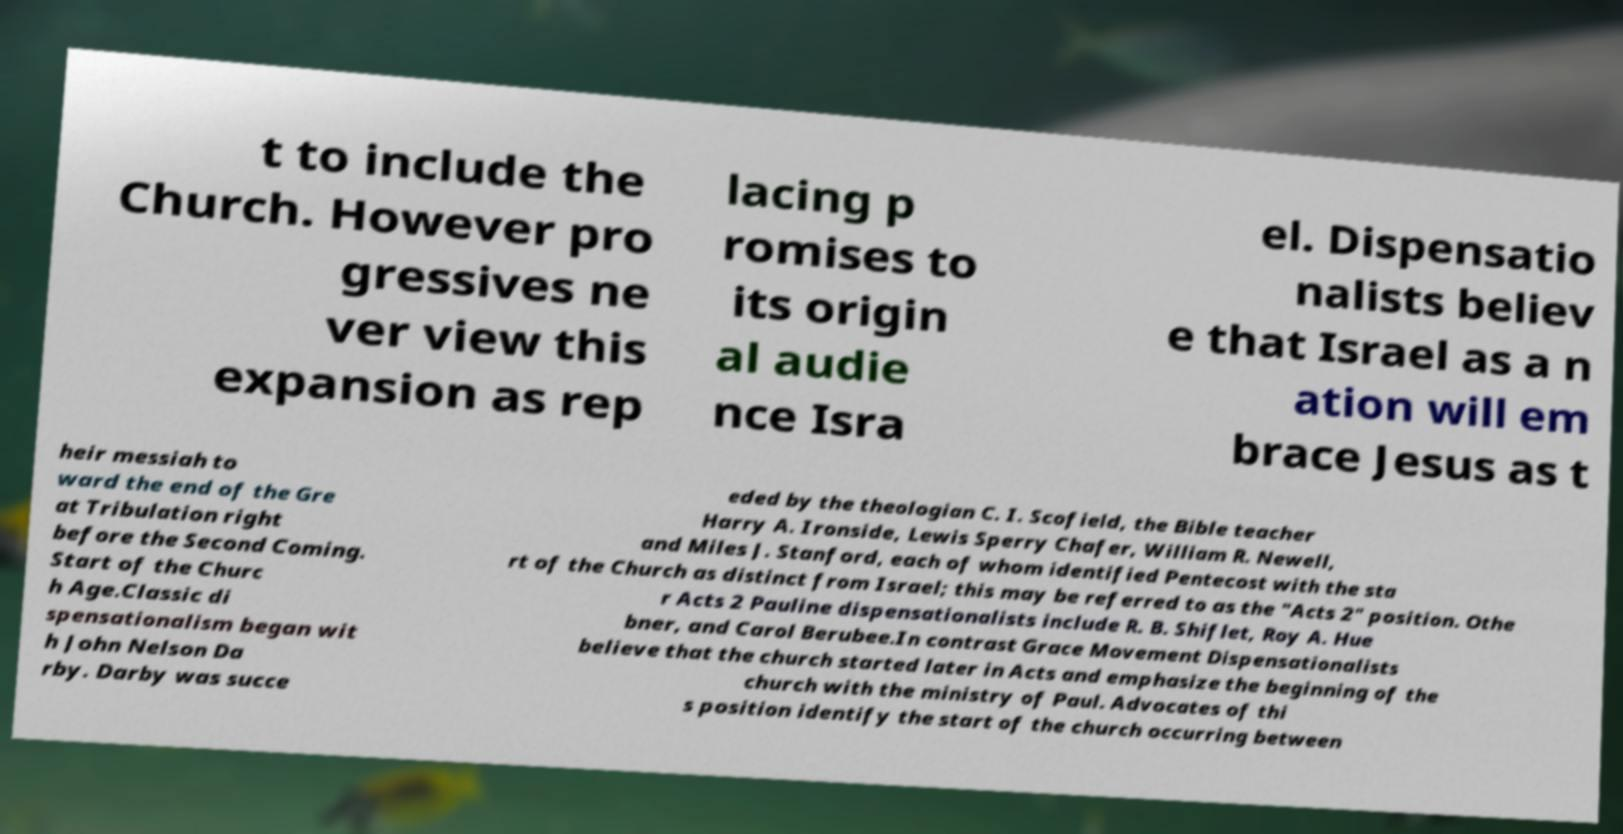Please read and relay the text visible in this image. What does it say? t to include the Church. However pro gressives ne ver view this expansion as rep lacing p romises to its origin al audie nce Isra el. Dispensatio nalists believ e that Israel as a n ation will em brace Jesus as t heir messiah to ward the end of the Gre at Tribulation right before the Second Coming. Start of the Churc h Age.Classic di spensationalism began wit h John Nelson Da rby. Darby was succe eded by the theologian C. I. Scofield, the Bible teacher Harry A. Ironside, Lewis Sperry Chafer, William R. Newell, and Miles J. Stanford, each of whom identified Pentecost with the sta rt of the Church as distinct from Israel; this may be referred to as the "Acts 2" position. Othe r Acts 2 Pauline dispensationalists include R. B. Shiflet, Roy A. Hue bner, and Carol Berubee.In contrast Grace Movement Dispensationalists believe that the church started later in Acts and emphasize the beginning of the church with the ministry of Paul. Advocates of thi s position identify the start of the church occurring between 